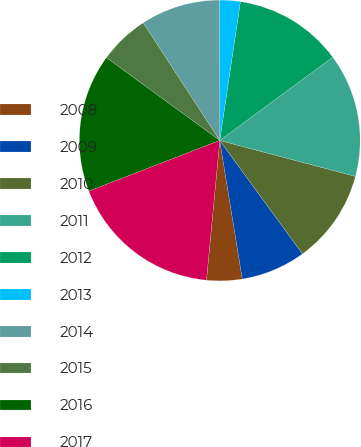Convert chart to OTSL. <chart><loc_0><loc_0><loc_500><loc_500><pie_chart><fcel>2008<fcel>2009<fcel>2010<fcel>2011<fcel>2012<fcel>2013<fcel>2014<fcel>2015<fcel>2016<fcel>2017<nl><fcel>4.08%<fcel>7.46%<fcel>10.85%<fcel>14.23%<fcel>12.54%<fcel>2.39%<fcel>9.15%<fcel>5.77%<fcel>15.92%<fcel>17.61%<nl></chart> 